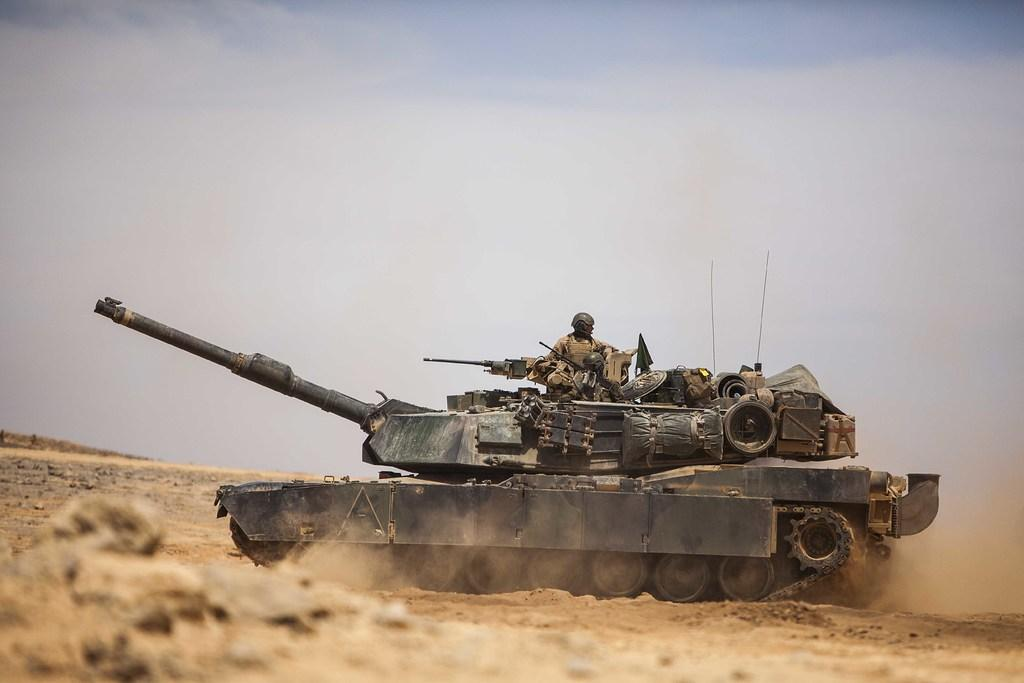What is the main object on the ground in the image? There is a tank on the ground in the image. Is there anyone interacting with the tank in the image? Yes, a person is on the tank. What can be seen in the background of the image? The sky is visible in the background of the image. Can you see any waves in the lake in the image? There is no lake or waves present in the image; it features a tank on the ground with a person on it, and the sky is visible in the background. 